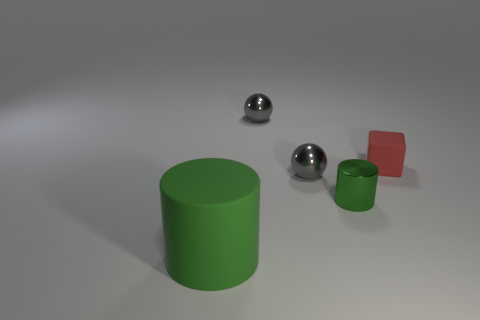What is the color of the cylinder on the right side of the matte thing in front of the tiny green cylinder?
Ensure brevity in your answer.  Green. Is the number of gray objects less than the number of things?
Give a very brief answer. Yes. What number of metallic objects are the same shape as the large green matte thing?
Offer a terse response. 1. There is a rubber object that is the same size as the green metallic cylinder; what color is it?
Keep it short and to the point. Red. Are there an equal number of big green rubber objects that are in front of the small red matte thing and tiny blocks on the left side of the large green matte object?
Make the answer very short. No. Are there any gray shiny objects that have the same size as the green shiny object?
Your response must be concise. Yes. The green rubber thing is what size?
Keep it short and to the point. Large. Are there an equal number of cylinders that are in front of the green metallic object and small purple metal cubes?
Provide a succinct answer. No. How many other objects are the same color as the big matte thing?
Give a very brief answer. 1. What size is the matte object right of the cylinder that is behind the rubber thing that is to the left of the red matte object?
Provide a succinct answer. Small. 